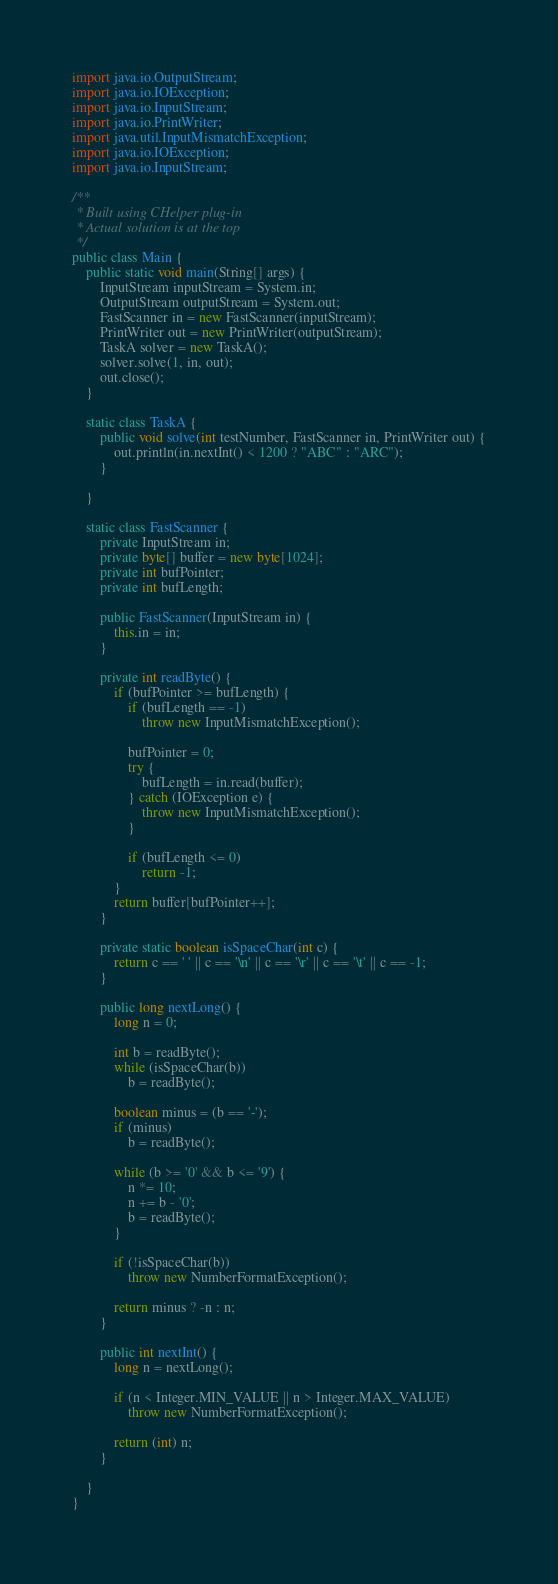<code> <loc_0><loc_0><loc_500><loc_500><_Java_>import java.io.OutputStream;
import java.io.IOException;
import java.io.InputStream;
import java.io.PrintWriter;
import java.util.InputMismatchException;
import java.io.IOException;
import java.io.InputStream;

/**
 * Built using CHelper plug-in
 * Actual solution is at the top
 */
public class Main {
    public static void main(String[] args) {
        InputStream inputStream = System.in;
        OutputStream outputStream = System.out;
        FastScanner in = new FastScanner(inputStream);
        PrintWriter out = new PrintWriter(outputStream);
        TaskA solver = new TaskA();
        solver.solve(1, in, out);
        out.close();
    }

    static class TaskA {
        public void solve(int testNumber, FastScanner in, PrintWriter out) {
            out.println(in.nextInt() < 1200 ? "ABC" : "ARC");
        }

    }

    static class FastScanner {
        private InputStream in;
        private byte[] buffer = new byte[1024];
        private int bufPointer;
        private int bufLength;

        public FastScanner(InputStream in) {
            this.in = in;
        }

        private int readByte() {
            if (bufPointer >= bufLength) {
                if (bufLength == -1)
                    throw new InputMismatchException();

                bufPointer = 0;
                try {
                    bufLength = in.read(buffer);
                } catch (IOException e) {
                    throw new InputMismatchException();
                }

                if (bufLength <= 0)
                    return -1;
            }
            return buffer[bufPointer++];
        }

        private static boolean isSpaceChar(int c) {
            return c == ' ' || c == '\n' || c == '\r' || c == '\t' || c == -1;
        }

        public long nextLong() {
            long n = 0;

            int b = readByte();
            while (isSpaceChar(b))
                b = readByte();

            boolean minus = (b == '-');
            if (minus)
                b = readByte();

            while (b >= '0' && b <= '9') {
                n *= 10;
                n += b - '0';
                b = readByte();
            }

            if (!isSpaceChar(b))
                throw new NumberFormatException();

            return minus ? -n : n;
        }

        public int nextInt() {
            long n = nextLong();

            if (n < Integer.MIN_VALUE || n > Integer.MAX_VALUE)
                throw new NumberFormatException();

            return (int) n;
        }

    }
}

</code> 